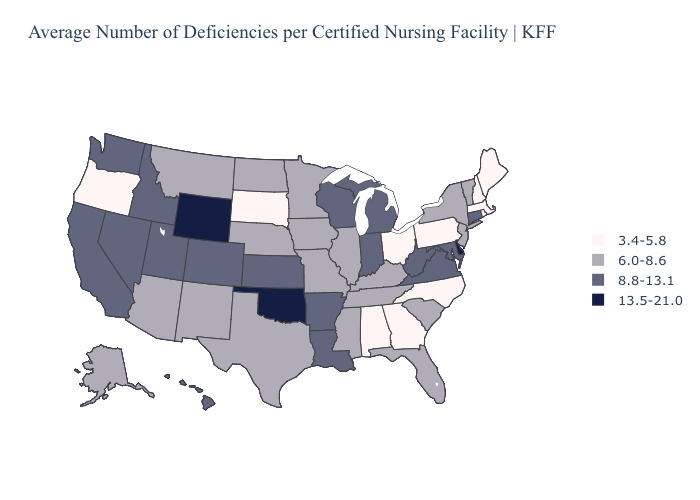Does Louisiana have the same value as Mississippi?
Keep it brief. No. Name the states that have a value in the range 3.4-5.8?
Answer briefly. Alabama, Georgia, Maine, Massachusetts, New Hampshire, North Carolina, Ohio, Oregon, Pennsylvania, Rhode Island, South Dakota. Does Rhode Island have the lowest value in the Northeast?
Concise answer only. Yes. What is the lowest value in the USA?
Answer briefly. 3.4-5.8. Name the states that have a value in the range 6.0-8.6?
Be succinct. Alaska, Arizona, Florida, Illinois, Iowa, Kentucky, Minnesota, Mississippi, Missouri, Montana, Nebraska, New Jersey, New Mexico, New York, North Dakota, South Carolina, Tennessee, Texas, Vermont. What is the lowest value in states that border Iowa?
Give a very brief answer. 3.4-5.8. Name the states that have a value in the range 13.5-21.0?
Give a very brief answer. Delaware, Oklahoma, Wyoming. How many symbols are there in the legend?
Be succinct. 4. Name the states that have a value in the range 13.5-21.0?
Give a very brief answer. Delaware, Oklahoma, Wyoming. What is the lowest value in the West?
Keep it brief. 3.4-5.8. What is the value of Rhode Island?
Concise answer only. 3.4-5.8. What is the lowest value in the West?
Write a very short answer. 3.4-5.8. What is the value of North Carolina?
Short answer required. 3.4-5.8. Name the states that have a value in the range 6.0-8.6?
Quick response, please. Alaska, Arizona, Florida, Illinois, Iowa, Kentucky, Minnesota, Mississippi, Missouri, Montana, Nebraska, New Jersey, New Mexico, New York, North Dakota, South Carolina, Tennessee, Texas, Vermont. What is the value of Missouri?
Keep it brief. 6.0-8.6. 